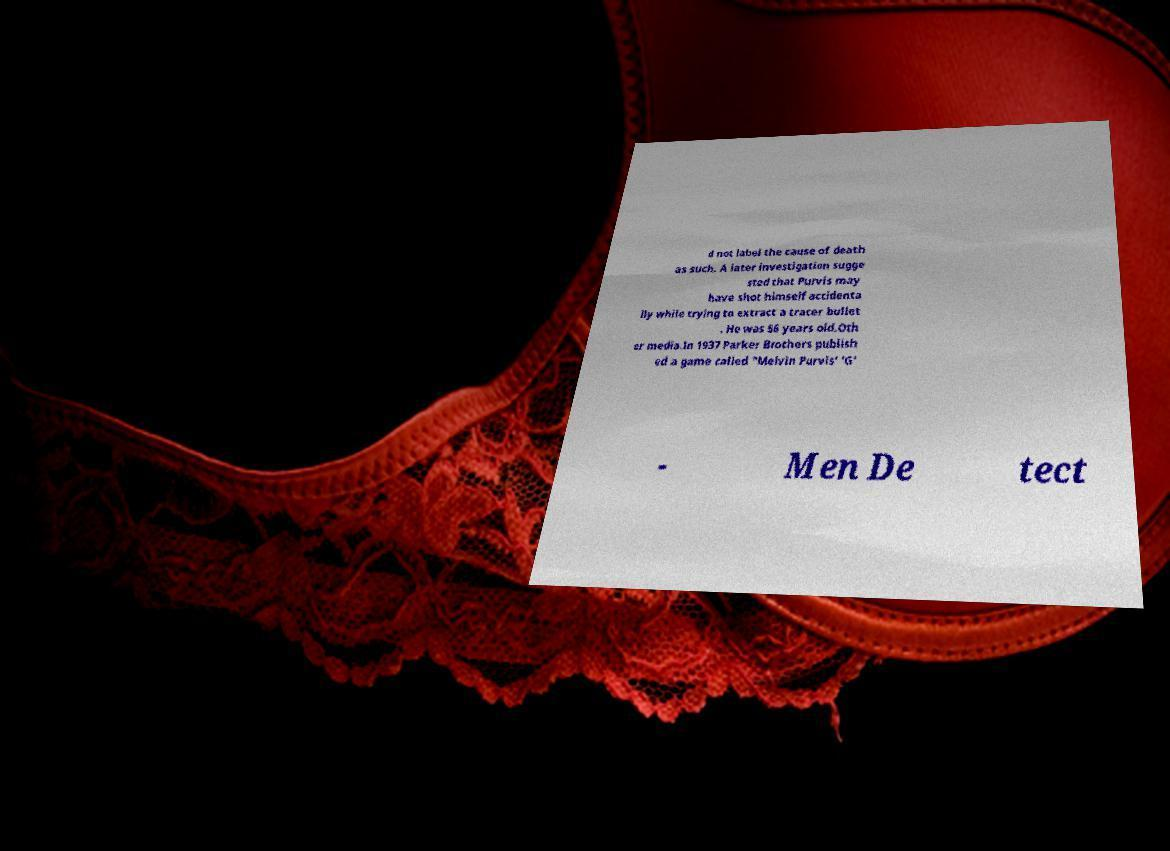Please read and relay the text visible in this image. What does it say? d not label the cause of death as such. A later investigation sugge sted that Purvis may have shot himself accidenta lly while trying to extract a tracer bullet . He was 56 years old.Oth er media.In 1937 Parker Brothers publish ed a game called "Melvin Purvis' 'G' - Men De tect 